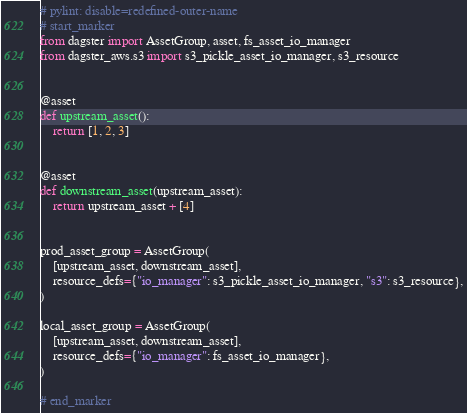Convert code to text. <code><loc_0><loc_0><loc_500><loc_500><_Python_># pylint: disable=redefined-outer-name
# start_marker
from dagster import AssetGroup, asset, fs_asset_io_manager
from dagster_aws.s3 import s3_pickle_asset_io_manager, s3_resource


@asset
def upstream_asset():
    return [1, 2, 3]


@asset
def downstream_asset(upstream_asset):
    return upstream_asset + [4]


prod_asset_group = AssetGroup(
    [upstream_asset, downstream_asset],
    resource_defs={"io_manager": s3_pickle_asset_io_manager, "s3": s3_resource},
)

local_asset_group = AssetGroup(
    [upstream_asset, downstream_asset],
    resource_defs={"io_manager": fs_asset_io_manager},
)

# end_marker
</code> 